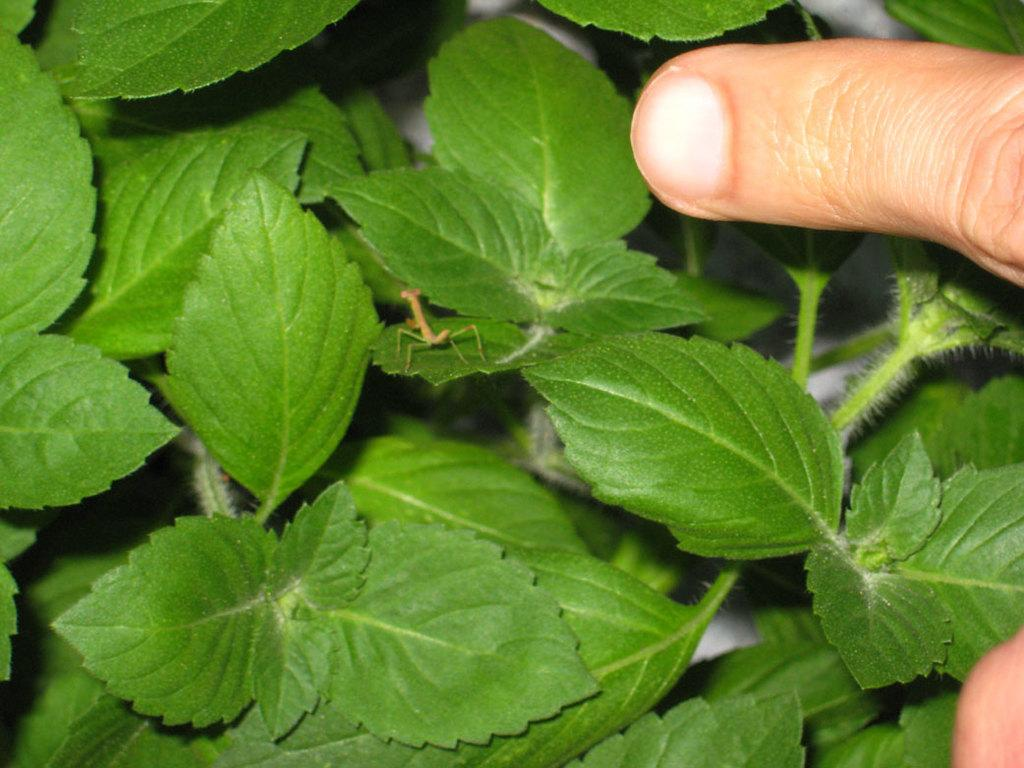What is located at the top side of the image? There is a finger at the top side of the image. What can be seen in the center of the image? There is an ant on a leaf in the center of the image. What type of vegetation is present in the image? There are leaves around the area of the image. What type of carriage can be seen in the image? There is no carriage present in the image. How many cakes are visible in the image? There are no cakes present in the image. 